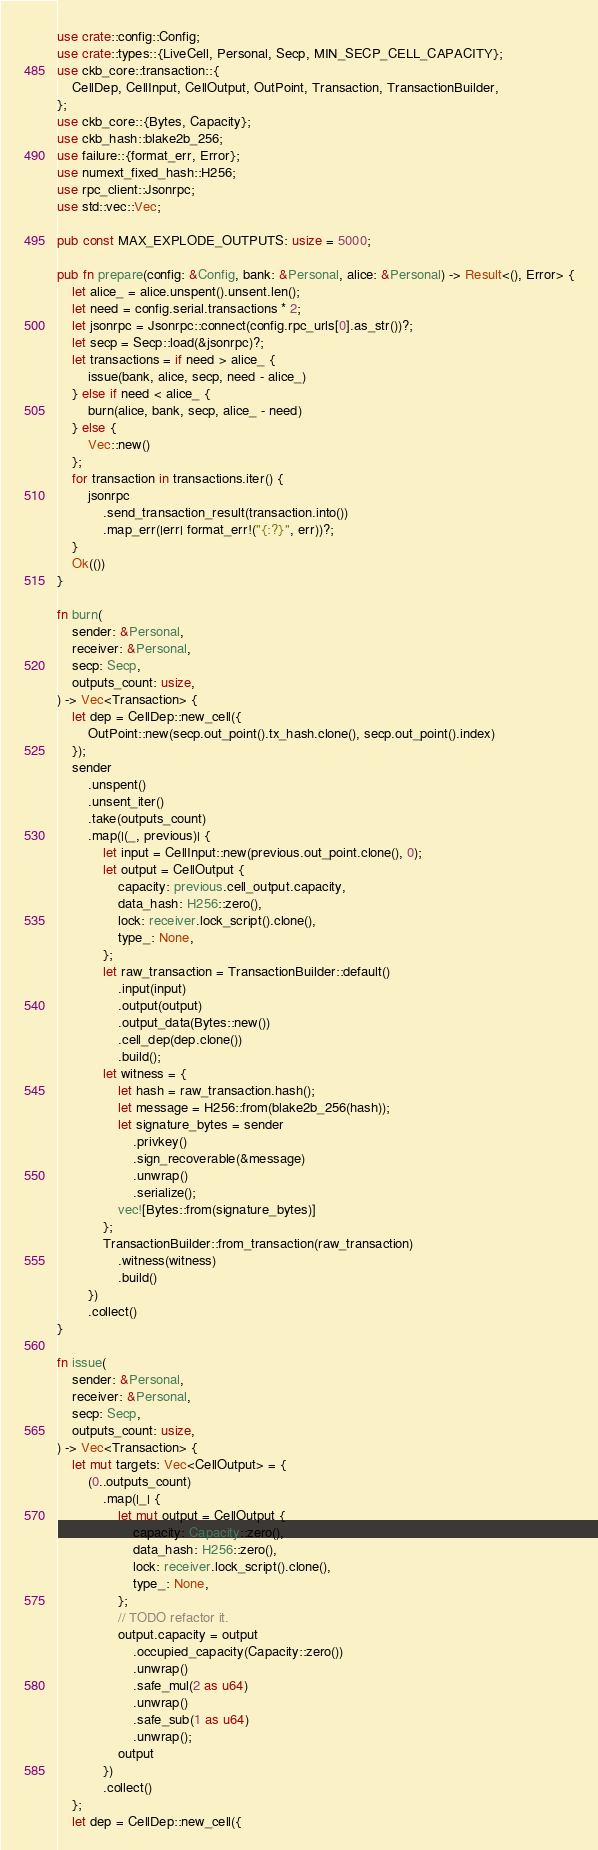Convert code to text. <code><loc_0><loc_0><loc_500><loc_500><_Rust_>use crate::config::Config;
use crate::types::{LiveCell, Personal, Secp, MIN_SECP_CELL_CAPACITY};
use ckb_core::transaction::{
    CellDep, CellInput, CellOutput, OutPoint, Transaction, TransactionBuilder,
};
use ckb_core::{Bytes, Capacity};
use ckb_hash::blake2b_256;
use failure::{format_err, Error};
use numext_fixed_hash::H256;
use rpc_client::Jsonrpc;
use std::vec::Vec;

pub const MAX_EXPLODE_OUTPUTS: usize = 5000;

pub fn prepare(config: &Config, bank: &Personal, alice: &Personal) -> Result<(), Error> {
    let alice_ = alice.unspent().unsent.len();
    let need = config.serial.transactions * 2;
    let jsonrpc = Jsonrpc::connect(config.rpc_urls[0].as_str())?;
    let secp = Secp::load(&jsonrpc)?;
    let transactions = if need > alice_ {
        issue(bank, alice, secp, need - alice_)
    } else if need < alice_ {
        burn(alice, bank, secp, alice_ - need)
    } else {
        Vec::new()
    };
    for transaction in transactions.iter() {
        jsonrpc
            .send_transaction_result(transaction.into())
            .map_err(|err| format_err!("{:?}", err))?;
    }
    Ok(())
}

fn burn(
    sender: &Personal,
    receiver: &Personal,
    secp: Secp,
    outputs_count: usize,
) -> Vec<Transaction> {
    let dep = CellDep::new_cell({
        OutPoint::new(secp.out_point().tx_hash.clone(), secp.out_point().index)
    });
    sender
        .unspent()
        .unsent_iter()
        .take(outputs_count)
        .map(|(_, previous)| {
            let input = CellInput::new(previous.out_point.clone(), 0);
            let output = CellOutput {
                capacity: previous.cell_output.capacity,
                data_hash: H256::zero(),
                lock: receiver.lock_script().clone(),
                type_: None,
            };
            let raw_transaction = TransactionBuilder::default()
                .input(input)
                .output(output)
                .output_data(Bytes::new())
                .cell_dep(dep.clone())
                .build();
            let witness = {
                let hash = raw_transaction.hash();
                let message = H256::from(blake2b_256(hash));
                let signature_bytes = sender
                    .privkey()
                    .sign_recoverable(&message)
                    .unwrap()
                    .serialize();
                vec![Bytes::from(signature_bytes)]
            };
            TransactionBuilder::from_transaction(raw_transaction)
                .witness(witness)
                .build()
        })
        .collect()
}

fn issue(
    sender: &Personal,
    receiver: &Personal,
    secp: Secp,
    outputs_count: usize,
) -> Vec<Transaction> {
    let mut targets: Vec<CellOutput> = {
        (0..outputs_count)
            .map(|_| {
                let mut output = CellOutput {
                    capacity: Capacity::zero(),
                    data_hash: H256::zero(),
                    lock: receiver.lock_script().clone(),
                    type_: None,
                };
                // TODO refactor it.
                output.capacity = output
                    .occupied_capacity(Capacity::zero())
                    .unwrap()
                    .safe_mul(2 as u64)
                    .unwrap()
                    .safe_sub(1 as u64)
                    .unwrap();
                output
            })
            .collect()
    };
    let dep = CellDep::new_cell({</code> 